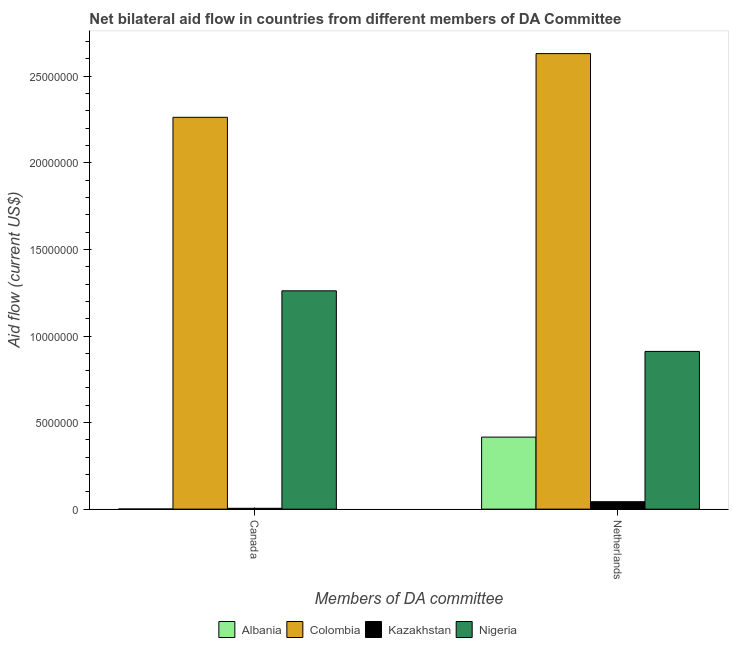How many bars are there on the 2nd tick from the left?
Offer a terse response. 4. What is the label of the 1st group of bars from the left?
Provide a succinct answer. Canada. What is the amount of aid given by netherlands in Nigeria?
Make the answer very short. 9.11e+06. Across all countries, what is the maximum amount of aid given by netherlands?
Your response must be concise. 2.63e+07. Across all countries, what is the minimum amount of aid given by netherlands?
Ensure brevity in your answer.  4.30e+05. In which country was the amount of aid given by canada maximum?
Your response must be concise. Colombia. In which country was the amount of aid given by canada minimum?
Your answer should be very brief. Albania. What is the total amount of aid given by netherlands in the graph?
Keep it short and to the point. 4.00e+07. What is the difference between the amount of aid given by netherlands in Colombia and that in Albania?
Offer a very short reply. 2.22e+07. What is the difference between the amount of aid given by canada in Nigeria and the amount of aid given by netherlands in Colombia?
Your response must be concise. -1.37e+07. What is the average amount of aid given by netherlands per country?
Make the answer very short. 1.00e+07. What is the difference between the amount of aid given by netherlands and amount of aid given by canada in Nigeria?
Offer a very short reply. -3.50e+06. In how many countries, is the amount of aid given by netherlands greater than 8000000 US$?
Give a very brief answer. 2. What is the ratio of the amount of aid given by canada in Nigeria to that in Albania?
Your answer should be very brief. 1261. Is the amount of aid given by canada in Nigeria less than that in Kazakhstan?
Make the answer very short. No. What does the 2nd bar from the right in Canada represents?
Your response must be concise. Kazakhstan. How many bars are there?
Ensure brevity in your answer.  8. Are all the bars in the graph horizontal?
Give a very brief answer. No. How many countries are there in the graph?
Give a very brief answer. 4. Does the graph contain any zero values?
Provide a short and direct response. No. Does the graph contain grids?
Ensure brevity in your answer.  No. What is the title of the graph?
Your response must be concise. Net bilateral aid flow in countries from different members of DA Committee. Does "Bhutan" appear as one of the legend labels in the graph?
Make the answer very short. No. What is the label or title of the X-axis?
Make the answer very short. Members of DA committee. What is the label or title of the Y-axis?
Your answer should be very brief. Aid flow (current US$). What is the Aid flow (current US$) of Colombia in Canada?
Your answer should be very brief. 2.26e+07. What is the Aid flow (current US$) in Nigeria in Canada?
Make the answer very short. 1.26e+07. What is the Aid flow (current US$) of Albania in Netherlands?
Your answer should be compact. 4.16e+06. What is the Aid flow (current US$) of Colombia in Netherlands?
Your answer should be very brief. 2.63e+07. What is the Aid flow (current US$) in Nigeria in Netherlands?
Keep it short and to the point. 9.11e+06. Across all Members of DA committee, what is the maximum Aid flow (current US$) in Albania?
Make the answer very short. 4.16e+06. Across all Members of DA committee, what is the maximum Aid flow (current US$) of Colombia?
Your response must be concise. 2.63e+07. Across all Members of DA committee, what is the maximum Aid flow (current US$) in Kazakhstan?
Offer a very short reply. 4.30e+05. Across all Members of DA committee, what is the maximum Aid flow (current US$) of Nigeria?
Offer a terse response. 1.26e+07. Across all Members of DA committee, what is the minimum Aid flow (current US$) of Colombia?
Provide a short and direct response. 2.26e+07. Across all Members of DA committee, what is the minimum Aid flow (current US$) in Kazakhstan?
Offer a terse response. 5.00e+04. Across all Members of DA committee, what is the minimum Aid flow (current US$) in Nigeria?
Provide a short and direct response. 9.11e+06. What is the total Aid flow (current US$) in Albania in the graph?
Ensure brevity in your answer.  4.17e+06. What is the total Aid flow (current US$) in Colombia in the graph?
Your answer should be compact. 4.89e+07. What is the total Aid flow (current US$) of Nigeria in the graph?
Give a very brief answer. 2.17e+07. What is the difference between the Aid flow (current US$) in Albania in Canada and that in Netherlands?
Keep it short and to the point. -4.15e+06. What is the difference between the Aid flow (current US$) in Colombia in Canada and that in Netherlands?
Give a very brief answer. -3.68e+06. What is the difference between the Aid flow (current US$) of Kazakhstan in Canada and that in Netherlands?
Ensure brevity in your answer.  -3.80e+05. What is the difference between the Aid flow (current US$) in Nigeria in Canada and that in Netherlands?
Give a very brief answer. 3.50e+06. What is the difference between the Aid flow (current US$) of Albania in Canada and the Aid flow (current US$) of Colombia in Netherlands?
Provide a succinct answer. -2.63e+07. What is the difference between the Aid flow (current US$) in Albania in Canada and the Aid flow (current US$) in Kazakhstan in Netherlands?
Give a very brief answer. -4.20e+05. What is the difference between the Aid flow (current US$) in Albania in Canada and the Aid flow (current US$) in Nigeria in Netherlands?
Your answer should be compact. -9.10e+06. What is the difference between the Aid flow (current US$) of Colombia in Canada and the Aid flow (current US$) of Kazakhstan in Netherlands?
Offer a very short reply. 2.22e+07. What is the difference between the Aid flow (current US$) of Colombia in Canada and the Aid flow (current US$) of Nigeria in Netherlands?
Ensure brevity in your answer.  1.35e+07. What is the difference between the Aid flow (current US$) in Kazakhstan in Canada and the Aid flow (current US$) in Nigeria in Netherlands?
Provide a succinct answer. -9.06e+06. What is the average Aid flow (current US$) of Albania per Members of DA committee?
Make the answer very short. 2.08e+06. What is the average Aid flow (current US$) of Colombia per Members of DA committee?
Ensure brevity in your answer.  2.45e+07. What is the average Aid flow (current US$) in Nigeria per Members of DA committee?
Your answer should be very brief. 1.09e+07. What is the difference between the Aid flow (current US$) of Albania and Aid flow (current US$) of Colombia in Canada?
Give a very brief answer. -2.26e+07. What is the difference between the Aid flow (current US$) of Albania and Aid flow (current US$) of Nigeria in Canada?
Your answer should be very brief. -1.26e+07. What is the difference between the Aid flow (current US$) of Colombia and Aid flow (current US$) of Kazakhstan in Canada?
Make the answer very short. 2.26e+07. What is the difference between the Aid flow (current US$) of Colombia and Aid flow (current US$) of Nigeria in Canada?
Provide a short and direct response. 1.00e+07. What is the difference between the Aid flow (current US$) of Kazakhstan and Aid flow (current US$) of Nigeria in Canada?
Your answer should be compact. -1.26e+07. What is the difference between the Aid flow (current US$) of Albania and Aid flow (current US$) of Colombia in Netherlands?
Provide a short and direct response. -2.22e+07. What is the difference between the Aid flow (current US$) in Albania and Aid flow (current US$) in Kazakhstan in Netherlands?
Make the answer very short. 3.73e+06. What is the difference between the Aid flow (current US$) in Albania and Aid flow (current US$) in Nigeria in Netherlands?
Your response must be concise. -4.95e+06. What is the difference between the Aid flow (current US$) of Colombia and Aid flow (current US$) of Kazakhstan in Netherlands?
Your response must be concise. 2.59e+07. What is the difference between the Aid flow (current US$) in Colombia and Aid flow (current US$) in Nigeria in Netherlands?
Make the answer very short. 1.72e+07. What is the difference between the Aid flow (current US$) of Kazakhstan and Aid flow (current US$) of Nigeria in Netherlands?
Keep it short and to the point. -8.68e+06. What is the ratio of the Aid flow (current US$) in Albania in Canada to that in Netherlands?
Your answer should be compact. 0. What is the ratio of the Aid flow (current US$) of Colombia in Canada to that in Netherlands?
Provide a short and direct response. 0.86. What is the ratio of the Aid flow (current US$) in Kazakhstan in Canada to that in Netherlands?
Provide a short and direct response. 0.12. What is the ratio of the Aid flow (current US$) of Nigeria in Canada to that in Netherlands?
Ensure brevity in your answer.  1.38. What is the difference between the highest and the second highest Aid flow (current US$) in Albania?
Provide a succinct answer. 4.15e+06. What is the difference between the highest and the second highest Aid flow (current US$) of Colombia?
Your answer should be compact. 3.68e+06. What is the difference between the highest and the second highest Aid flow (current US$) of Nigeria?
Offer a very short reply. 3.50e+06. What is the difference between the highest and the lowest Aid flow (current US$) of Albania?
Offer a very short reply. 4.15e+06. What is the difference between the highest and the lowest Aid flow (current US$) of Colombia?
Provide a short and direct response. 3.68e+06. What is the difference between the highest and the lowest Aid flow (current US$) of Kazakhstan?
Offer a very short reply. 3.80e+05. What is the difference between the highest and the lowest Aid flow (current US$) of Nigeria?
Your answer should be compact. 3.50e+06. 